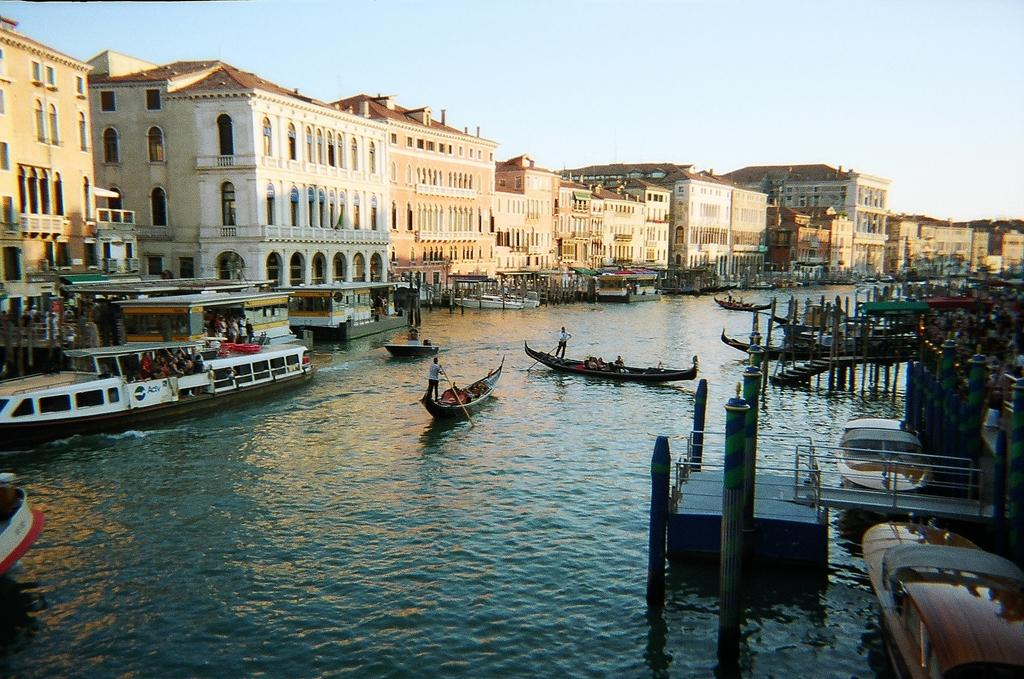What type of vehicles are in the image? There are boats in the image. Where are the boats located? The boats are on the water. What structures are near the boats? There are buildings beside the boats. What time of day is it in the image, based on the position of the beds? There are no beds present in the image, so it is not possible to determine the time of day based on their position. 